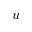<formula> <loc_0><loc_0><loc_500><loc_500>u</formula> 